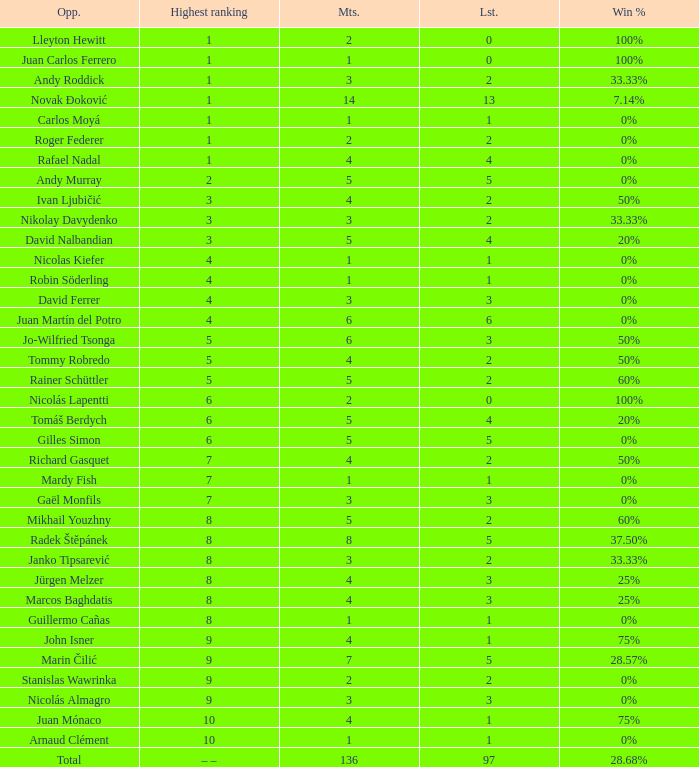What is the largest number Lost to david nalbandian with a Win Rate of 20%? 4.0. 